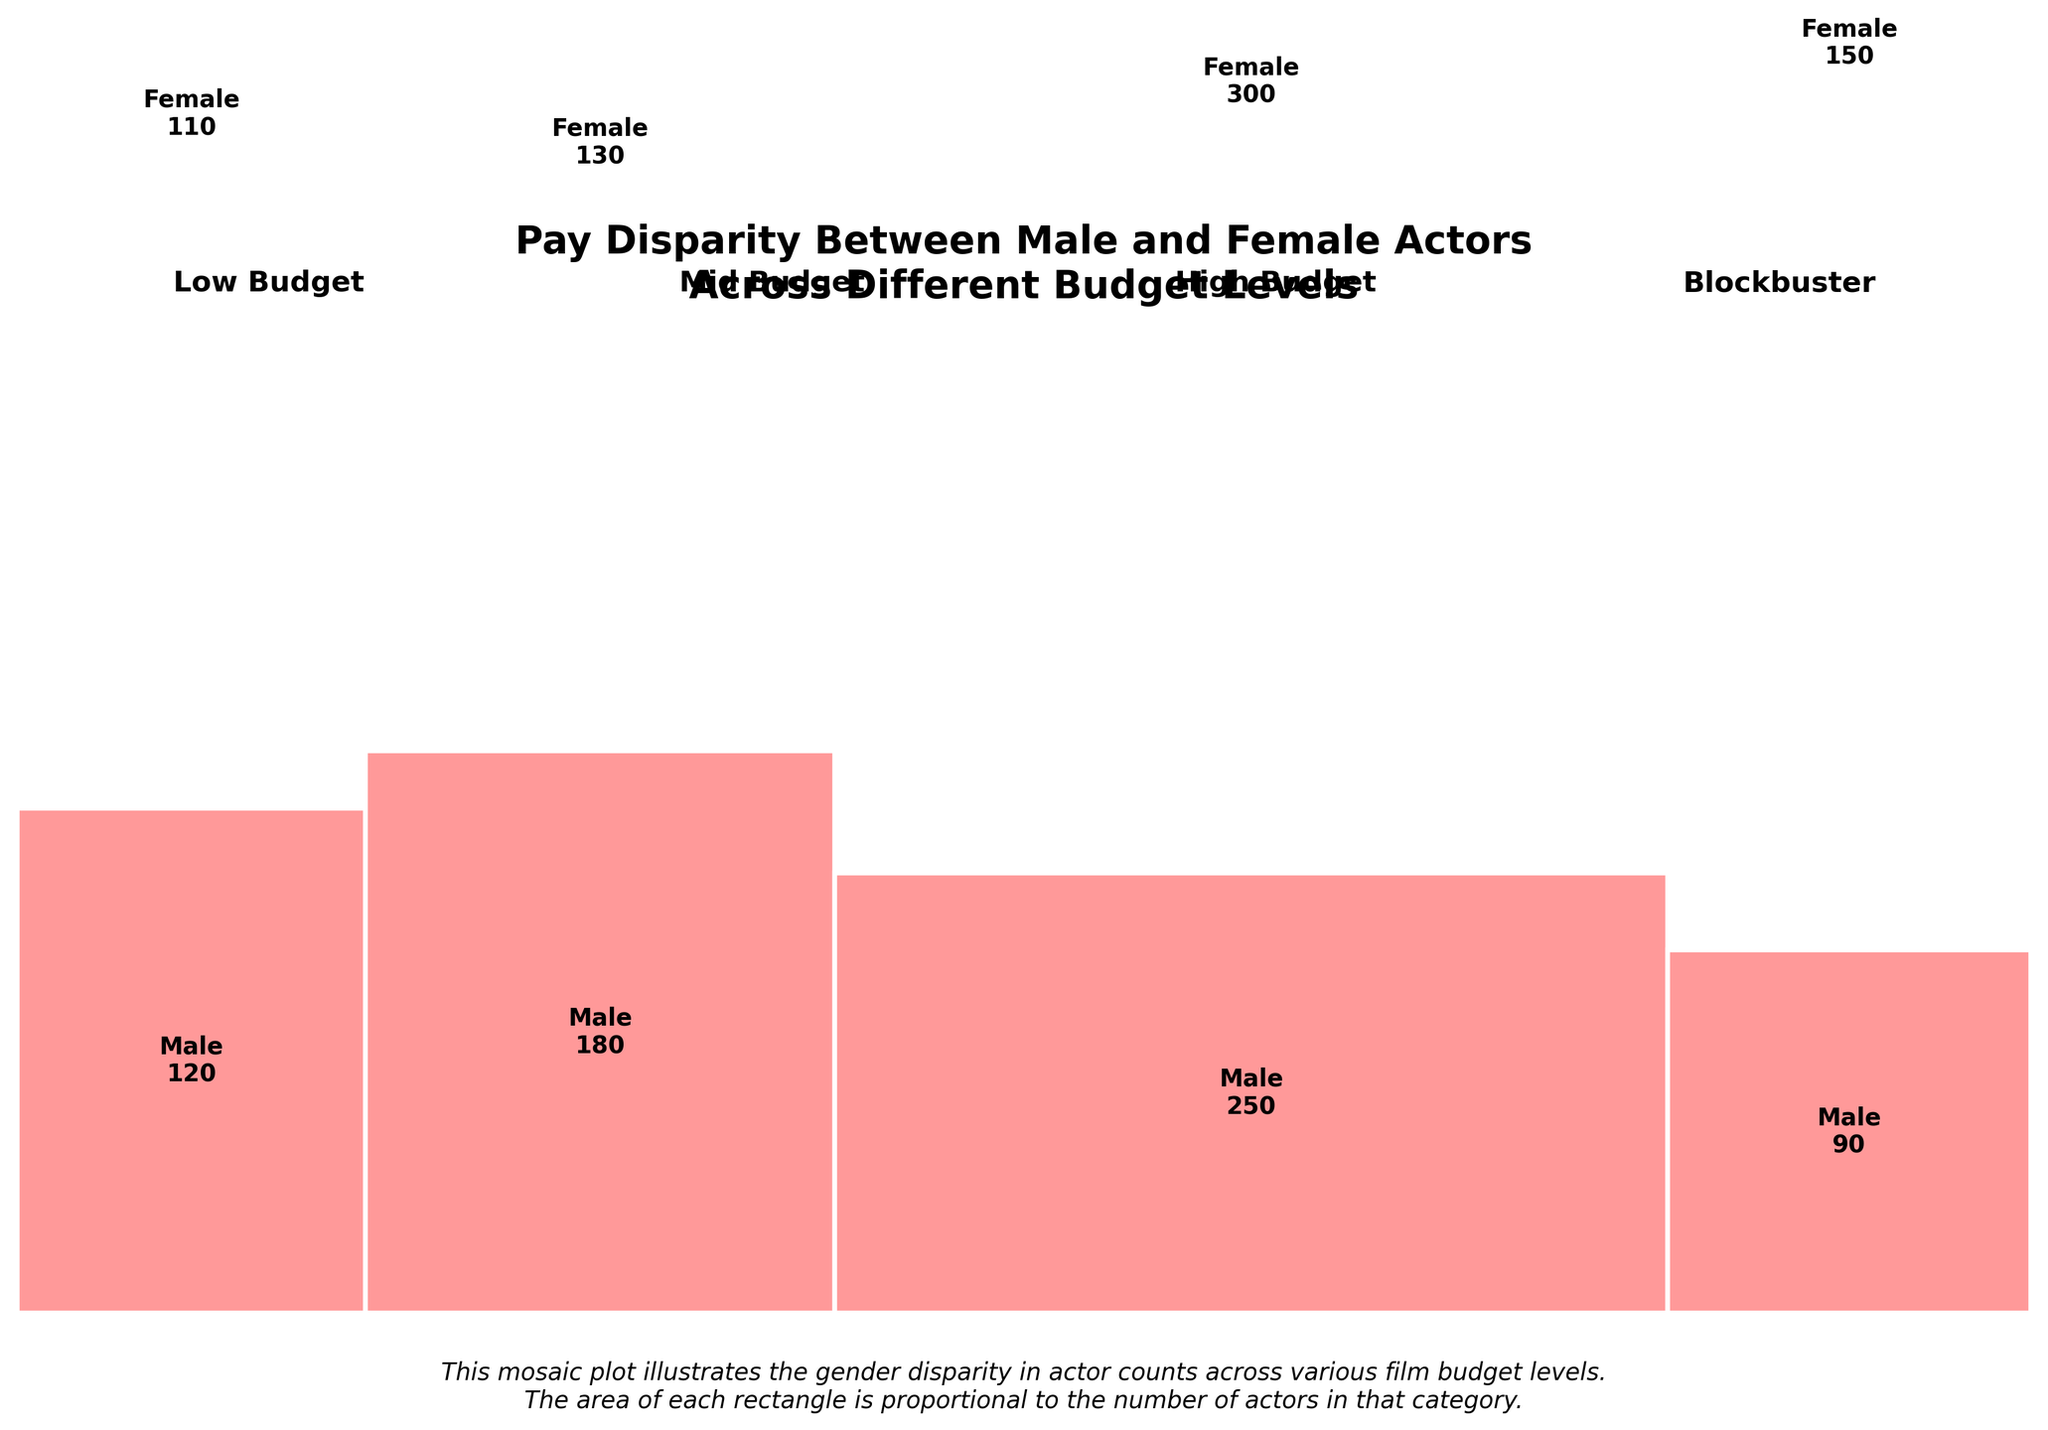What's the title of the plot? The title is shown at the top of the figure and provides a brief summary of the plot's content. The title can be observed by looking at the prominent text at the top of the image.
Answer: Pay Disparity Between Male and Female Actors Across Different Budget Levels What color represents females in the plot? The plot uses two distinct colors to represent male and female actors. By examining the color associated with the "Female" label within each budget level, we can identify the color used for females.
Answer: Light blue How many male actors are there in Blockbuster films? The number of male actors in each budget level is shown within the rectangles for each category. For Blockbuster films, locate the rectangle for males and read the number displayed inside it.
Answer: 300 What budget level has the smallest count of female actors? To find the smallest count of female actors, compare the values displayed inside the female rectangles across all budget levels and identify the smallest one.
Answer: Low Budget What's the overall trend in the number of male actors across budget levels? Observe the size and number within the male rectangles across different budget levels and note how it changes from Low Budget to Blockbuster.
Answer: Increasing trend What's the total count of male actors across all budget levels? Sum up the numbers displayed within all the male rectangles across different budget levels: 120 + 180 + 250 + 300.
Answer: 850 What's the ratio of male to female actors in high-budget films? Compare the count of male actors to the count of female actors in high-budget films. The values are respectively 250 for males and 130 for females, so calculate the ratio 250:130. Simplify the ratio if possible.
Answer: 250:130 or approximately 1.92:1 Which budget level shows the greatest gender disparity? Identify which budget level has the largest difference between the number of male and female actors. Compare the differences between male and female counts for each budget level.
Answer: Blockbuster How does the number of female actors in low-budget films compare to mid-budget films? Compare the counts for female actors in low-budget films (90) to those in mid-budget films (110).
Answer: Less in low-budget films In which budget level are males and females closest in numbers? Compare the counts of males and females in each budget level and identify the budget level where the difference between the two numbers is the smallest.
Answer: High Budget 